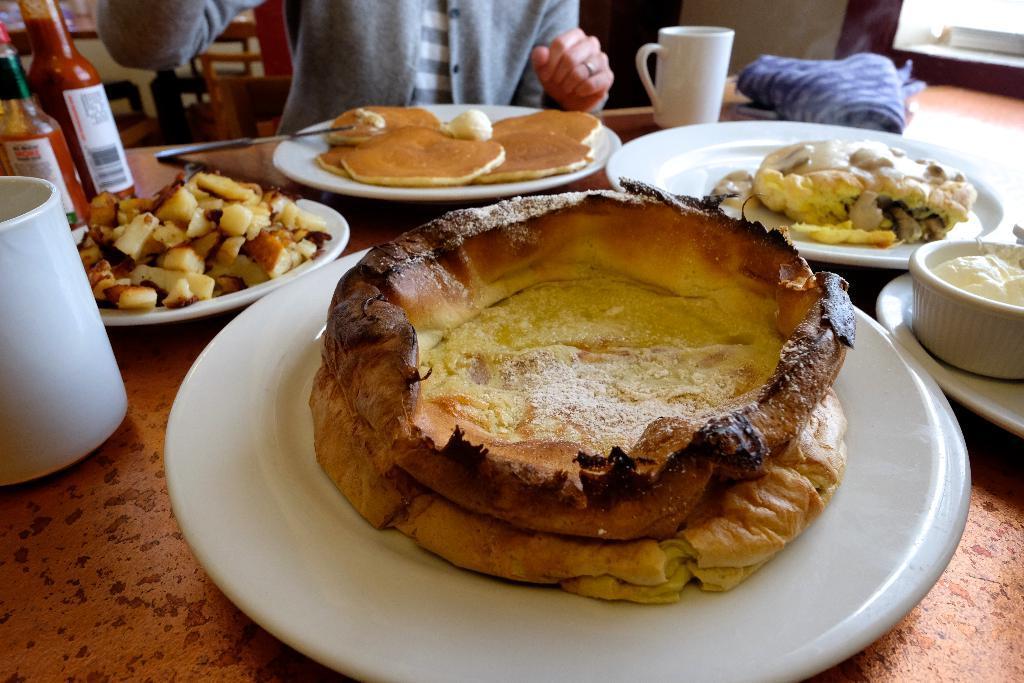How would you summarize this image in a sentence or two? In this image I see the table on which there are white plates on which there is food which is of cream, brown and white in color and I see 2 white color cups and I see bottles over here and I see the white and blue color cloth over here and I see a person over here and I see a white cup in which there is white color cream. 